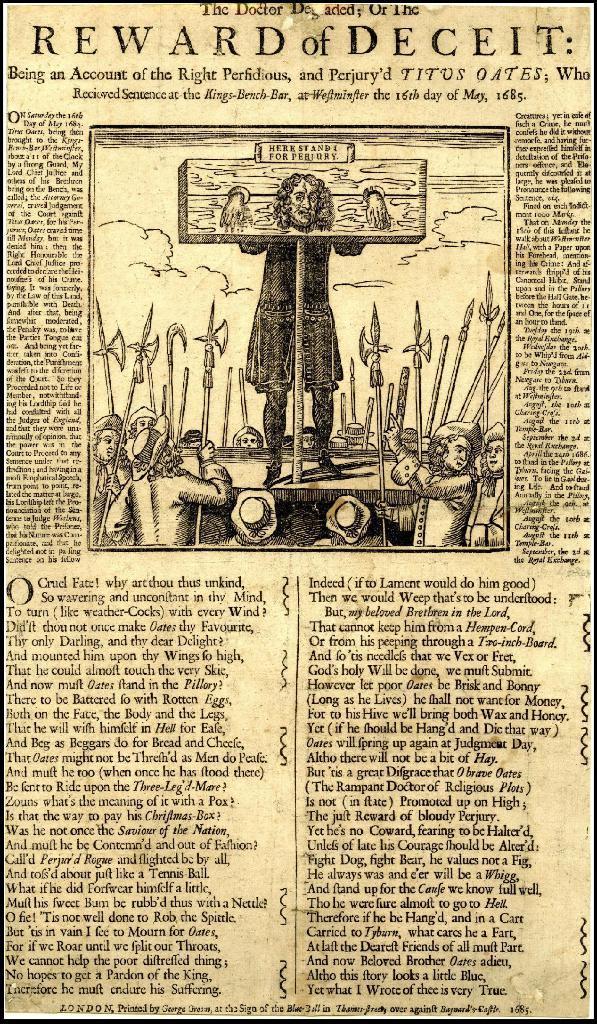Describe this image in one or two sentences. This image consists of newspaper where we can see text and picture. 